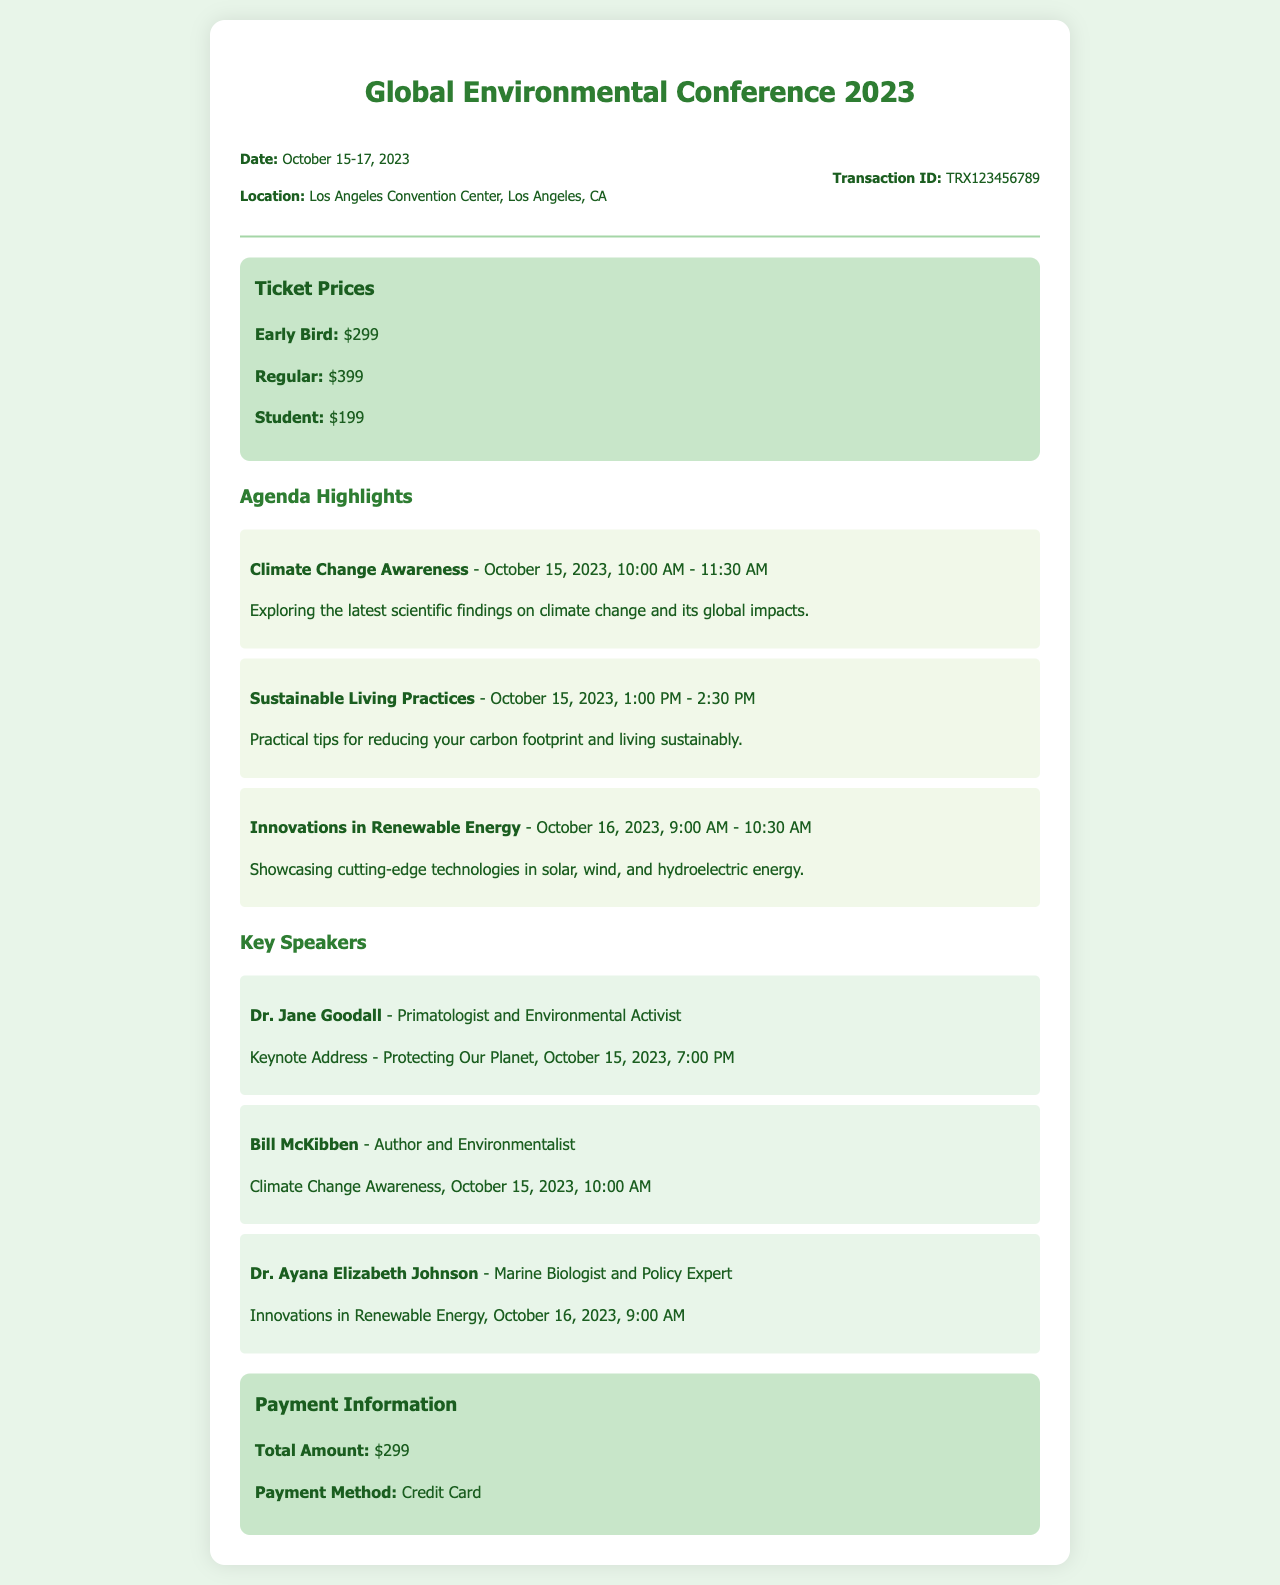What are the dates of the conference? The conference is scheduled from October 15 to 17, 2023.
Answer: October 15-17, 2023 Where is the conference taking place? The location of the conference is mentioned in the document.
Answer: Los Angeles Convention Center, Los Angeles, CA What is the price of an early bird ticket? The document lists the prices for different ticket types, including the early bird price.
Answer: $299 Who is delivering the keynote address? The document specifies the keynote speaker for the opening address.
Answer: Dr. Jane Goodall What topic is covered in the session on October 15 at 1:00 PM? The agenda highlights the topics of different sessions, including this particular one.
Answer: Sustainable Living Practices How much was paid in total for the ticket? The payment information section lists the total amount paid for the ticket.
Answer: $299 Who will speak about innovations in renewable energy? The document provides the names of speakers along with the sessions they will speak in.
Answer: Dr. Ayana Elizabeth Johnson What is the payment method used? The payment information section contains details about the payment method.
Answer: Credit Card What is the time for the session on Climate Change Awareness? The agenda specifies the time for the Climate Change Awareness session.
Answer: 10:00 AM - 11:30 AM 